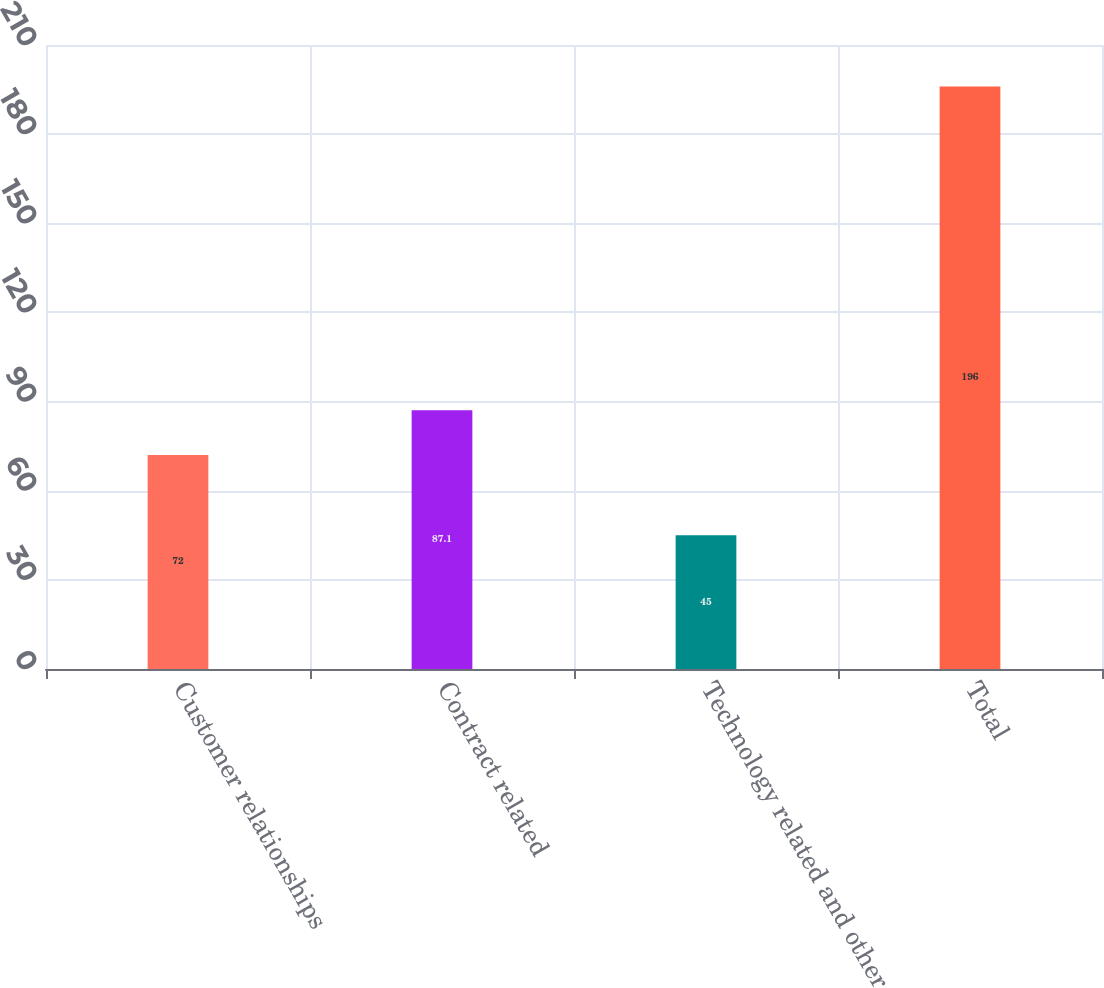Convert chart. <chart><loc_0><loc_0><loc_500><loc_500><bar_chart><fcel>Customer relationships<fcel>Contract related<fcel>Technology related and other<fcel>Total<nl><fcel>72<fcel>87.1<fcel>45<fcel>196<nl></chart> 